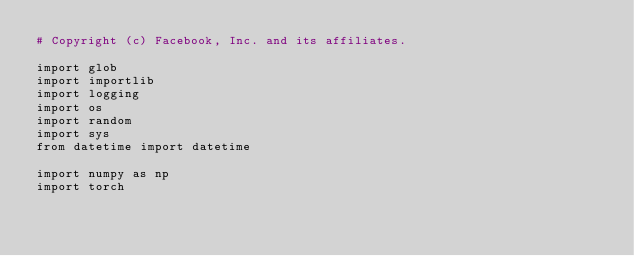<code> <loc_0><loc_0><loc_500><loc_500><_Python_># Copyright (c) Facebook, Inc. and its affiliates.

import glob
import importlib
import logging
import os
import random
import sys
from datetime import datetime

import numpy as np
import torch</code> 